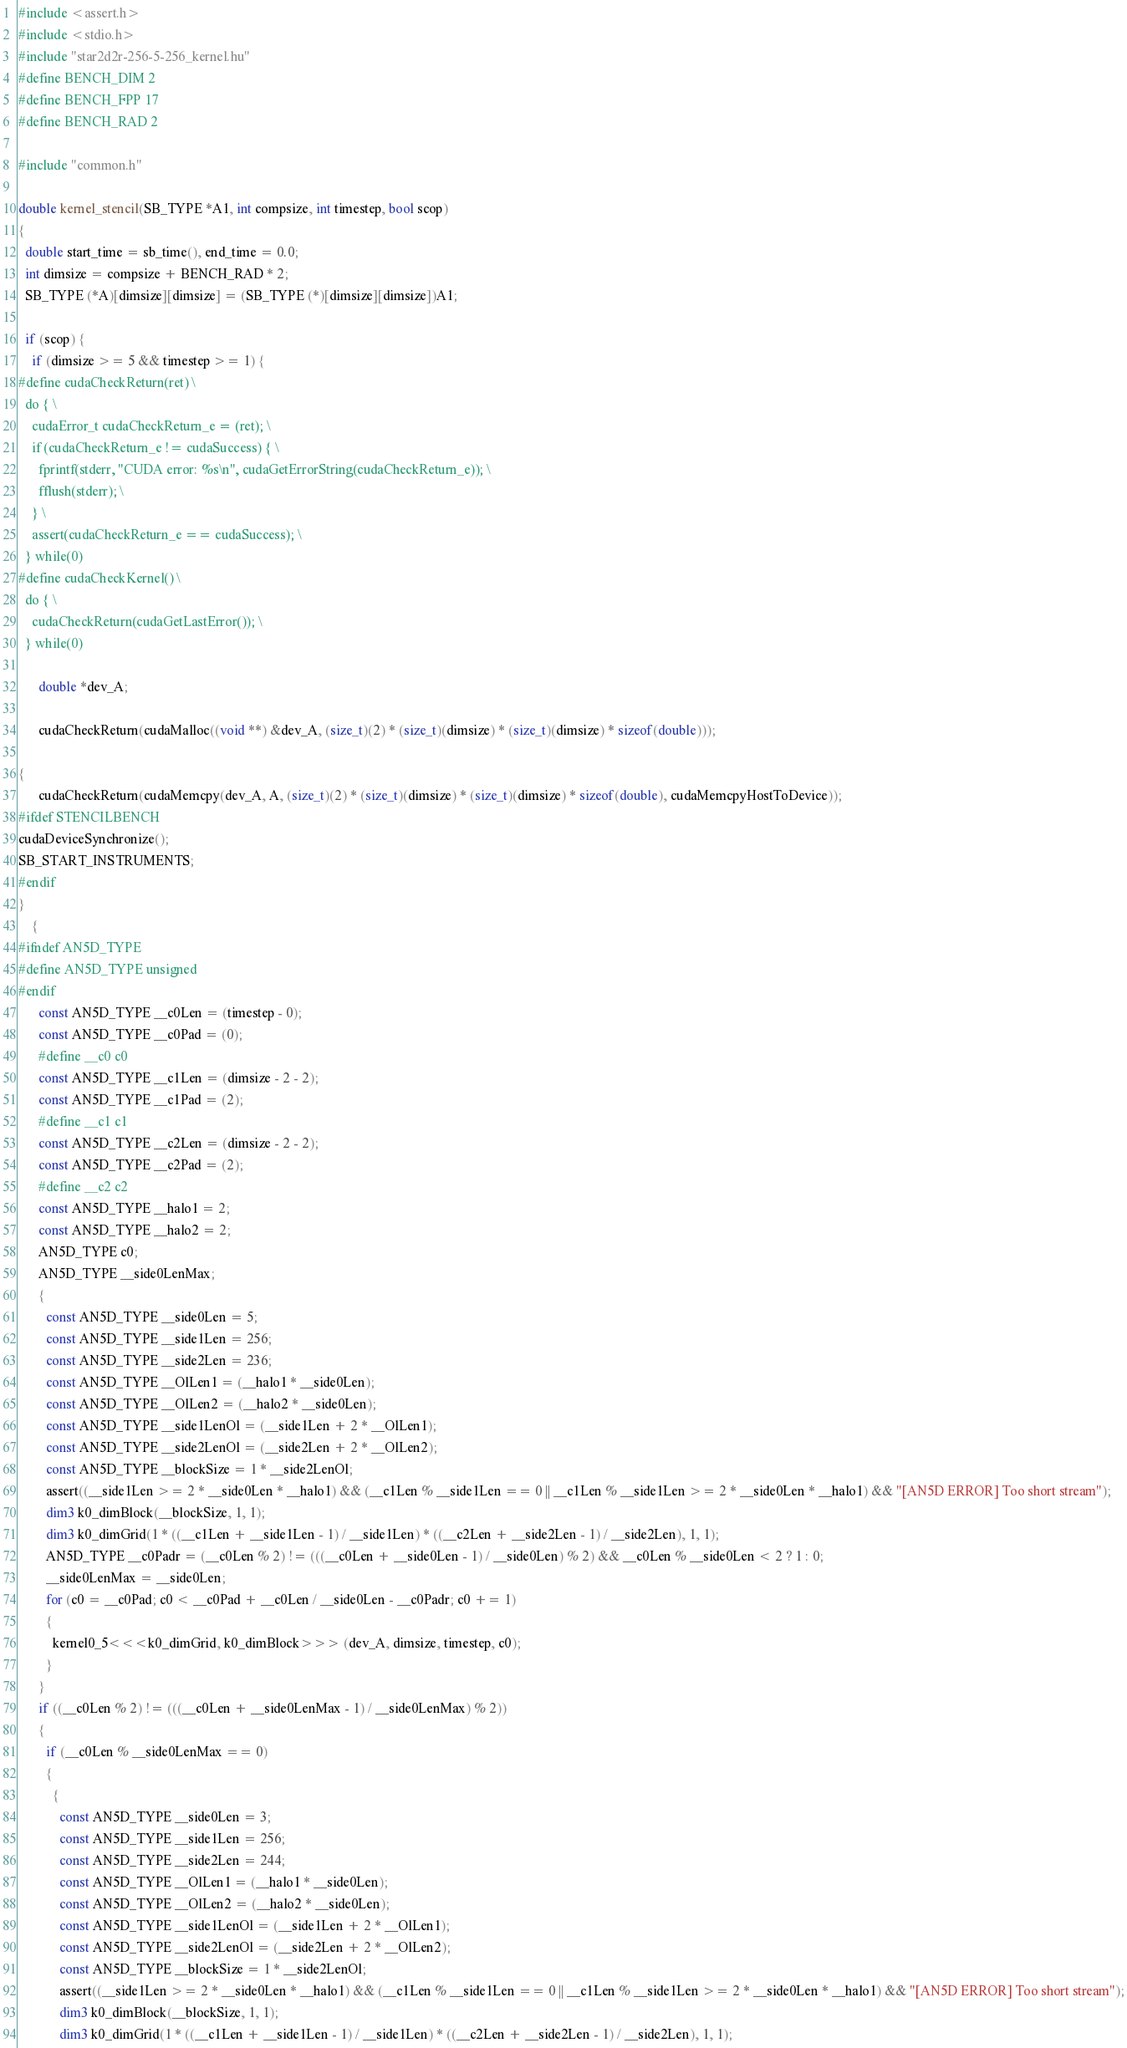<code> <loc_0><loc_0><loc_500><loc_500><_Cuda_>#include <assert.h>
#include <stdio.h>
#include "star2d2r-256-5-256_kernel.hu"
#define BENCH_DIM 2
#define BENCH_FPP 17
#define BENCH_RAD 2

#include "common.h"

double kernel_stencil(SB_TYPE *A1, int compsize, int timestep, bool scop)
{
  double start_time = sb_time(), end_time = 0.0;
  int dimsize = compsize + BENCH_RAD * 2;
  SB_TYPE (*A)[dimsize][dimsize] = (SB_TYPE (*)[dimsize][dimsize])A1;

  if (scop) {
    if (dimsize >= 5 && timestep >= 1) {
#define cudaCheckReturn(ret) \
  do { \
    cudaError_t cudaCheckReturn_e = (ret); \
    if (cudaCheckReturn_e != cudaSuccess) { \
      fprintf(stderr, "CUDA error: %s\n", cudaGetErrorString(cudaCheckReturn_e)); \
      fflush(stderr); \
    } \
    assert(cudaCheckReturn_e == cudaSuccess); \
  } while(0)
#define cudaCheckKernel() \
  do { \
    cudaCheckReturn(cudaGetLastError()); \
  } while(0)

      double *dev_A;
      
      cudaCheckReturn(cudaMalloc((void **) &dev_A, (size_t)(2) * (size_t)(dimsize) * (size_t)(dimsize) * sizeof(double)));
      
{
      cudaCheckReturn(cudaMemcpy(dev_A, A, (size_t)(2) * (size_t)(dimsize) * (size_t)(dimsize) * sizeof(double), cudaMemcpyHostToDevice));
#ifdef STENCILBENCH
cudaDeviceSynchronize();
SB_START_INSTRUMENTS;
#endif
}
    {
#ifndef AN5D_TYPE
#define AN5D_TYPE unsigned
#endif
      const AN5D_TYPE __c0Len = (timestep - 0);
      const AN5D_TYPE __c0Pad = (0);
      #define __c0 c0
      const AN5D_TYPE __c1Len = (dimsize - 2 - 2);
      const AN5D_TYPE __c1Pad = (2);
      #define __c1 c1
      const AN5D_TYPE __c2Len = (dimsize - 2 - 2);
      const AN5D_TYPE __c2Pad = (2);
      #define __c2 c2
      const AN5D_TYPE __halo1 = 2;
      const AN5D_TYPE __halo2 = 2;
      AN5D_TYPE c0;
      AN5D_TYPE __side0LenMax;
      {
        const AN5D_TYPE __side0Len = 5;
        const AN5D_TYPE __side1Len = 256;
        const AN5D_TYPE __side2Len = 236;
        const AN5D_TYPE __OlLen1 = (__halo1 * __side0Len);
        const AN5D_TYPE __OlLen2 = (__halo2 * __side0Len);
        const AN5D_TYPE __side1LenOl = (__side1Len + 2 * __OlLen1);
        const AN5D_TYPE __side2LenOl = (__side2Len + 2 * __OlLen2);
        const AN5D_TYPE __blockSize = 1 * __side2LenOl;
        assert((__side1Len >= 2 * __side0Len * __halo1) && (__c1Len % __side1Len == 0 || __c1Len % __side1Len >= 2 * __side0Len * __halo1) && "[AN5D ERROR] Too short stream");
        dim3 k0_dimBlock(__blockSize, 1, 1);
        dim3 k0_dimGrid(1 * ((__c1Len + __side1Len - 1) / __side1Len) * ((__c2Len + __side2Len - 1) / __side2Len), 1, 1);
        AN5D_TYPE __c0Padr = (__c0Len % 2) != (((__c0Len + __side0Len - 1) / __side0Len) % 2) && __c0Len % __side0Len < 2 ? 1 : 0;
        __side0LenMax = __side0Len;
        for (c0 = __c0Pad; c0 < __c0Pad + __c0Len / __side0Len - __c0Padr; c0 += 1)
        {
          kernel0_5<<<k0_dimGrid, k0_dimBlock>>> (dev_A, dimsize, timestep, c0);
        }
      }
      if ((__c0Len % 2) != (((__c0Len + __side0LenMax - 1) / __side0LenMax) % 2))
      {
        if (__c0Len % __side0LenMax == 0)
        {
          {
            const AN5D_TYPE __side0Len = 3;
            const AN5D_TYPE __side1Len = 256;
            const AN5D_TYPE __side2Len = 244;
            const AN5D_TYPE __OlLen1 = (__halo1 * __side0Len);
            const AN5D_TYPE __OlLen2 = (__halo2 * __side0Len);
            const AN5D_TYPE __side1LenOl = (__side1Len + 2 * __OlLen1);
            const AN5D_TYPE __side2LenOl = (__side2Len + 2 * __OlLen2);
            const AN5D_TYPE __blockSize = 1 * __side2LenOl;
            assert((__side1Len >= 2 * __side0Len * __halo1) && (__c1Len % __side1Len == 0 || __c1Len % __side1Len >= 2 * __side0Len * __halo1) && "[AN5D ERROR] Too short stream");
            dim3 k0_dimBlock(__blockSize, 1, 1);
            dim3 k0_dimGrid(1 * ((__c1Len + __side1Len - 1) / __side1Len) * ((__c2Len + __side2Len - 1) / __side2Len), 1, 1);</code> 